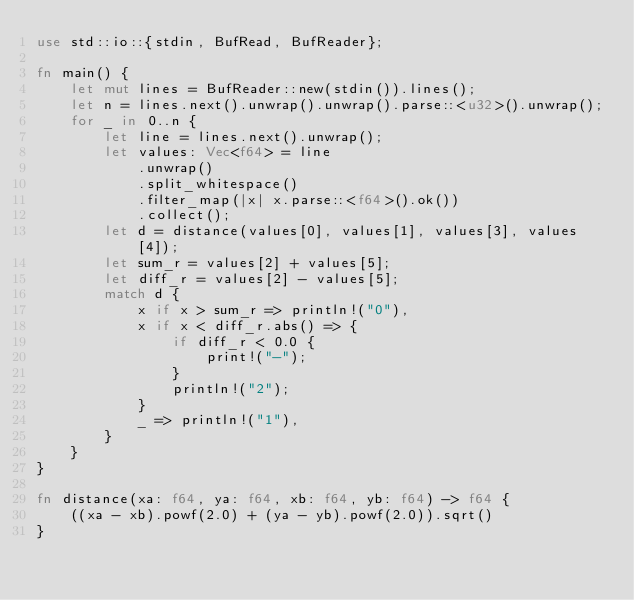<code> <loc_0><loc_0><loc_500><loc_500><_Rust_>use std::io::{stdin, BufRead, BufReader};

fn main() {
    let mut lines = BufReader::new(stdin()).lines();
    let n = lines.next().unwrap().unwrap().parse::<u32>().unwrap();
    for _ in 0..n {
        let line = lines.next().unwrap();
        let values: Vec<f64> = line
            .unwrap()
            .split_whitespace()
            .filter_map(|x| x.parse::<f64>().ok())
            .collect();
        let d = distance(values[0], values[1], values[3], values[4]);
        let sum_r = values[2] + values[5];
        let diff_r = values[2] - values[5];
        match d {
            x if x > sum_r => println!("0"),
            x if x < diff_r.abs() => {
                if diff_r < 0.0 {
                    print!("-");
                }
                println!("2");
            }
            _ => println!("1"),
        }
    }
}

fn distance(xa: f64, ya: f64, xb: f64, yb: f64) -> f64 {
    ((xa - xb).powf(2.0) + (ya - yb).powf(2.0)).sqrt()
}

</code> 